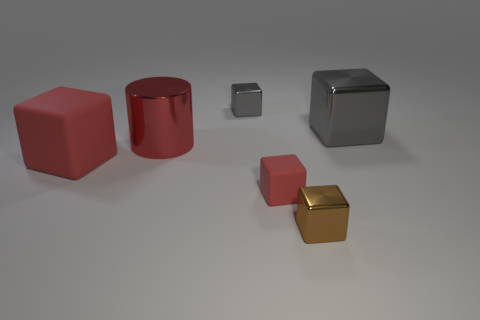Subtract all small rubber cubes. How many cubes are left? 4 Subtract all brown blocks. How many blocks are left? 4 Subtract all blue blocks. Subtract all cyan cylinders. How many blocks are left? 5 Add 4 big red rubber things. How many objects exist? 10 Subtract all cylinders. How many objects are left? 5 Add 2 cylinders. How many cylinders are left? 3 Add 3 gray shiny objects. How many gray shiny objects exist? 5 Subtract 0 purple blocks. How many objects are left? 6 Subtract all yellow metal cubes. Subtract all gray objects. How many objects are left? 4 